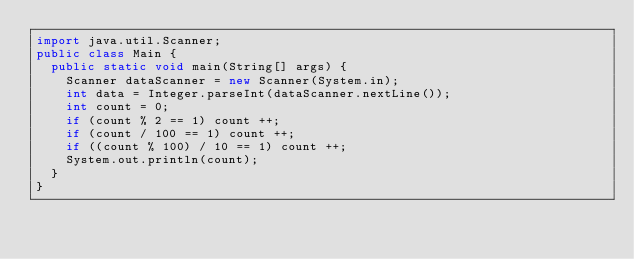<code> <loc_0><loc_0><loc_500><loc_500><_Java_>import java.util.Scanner;
public class Main {
  public static void main(String[] args) {
    Scanner dataScanner = new Scanner(System.in);
    int data = Integer.parseInt(dataScanner.nextLine());
    int count = 0;
    if (count % 2 == 1) count ++;
    if (count / 100 == 1) count ++;
    if ((count % 100) / 10 == 1) count ++;
    System.out.println(count);
  }
}
</code> 